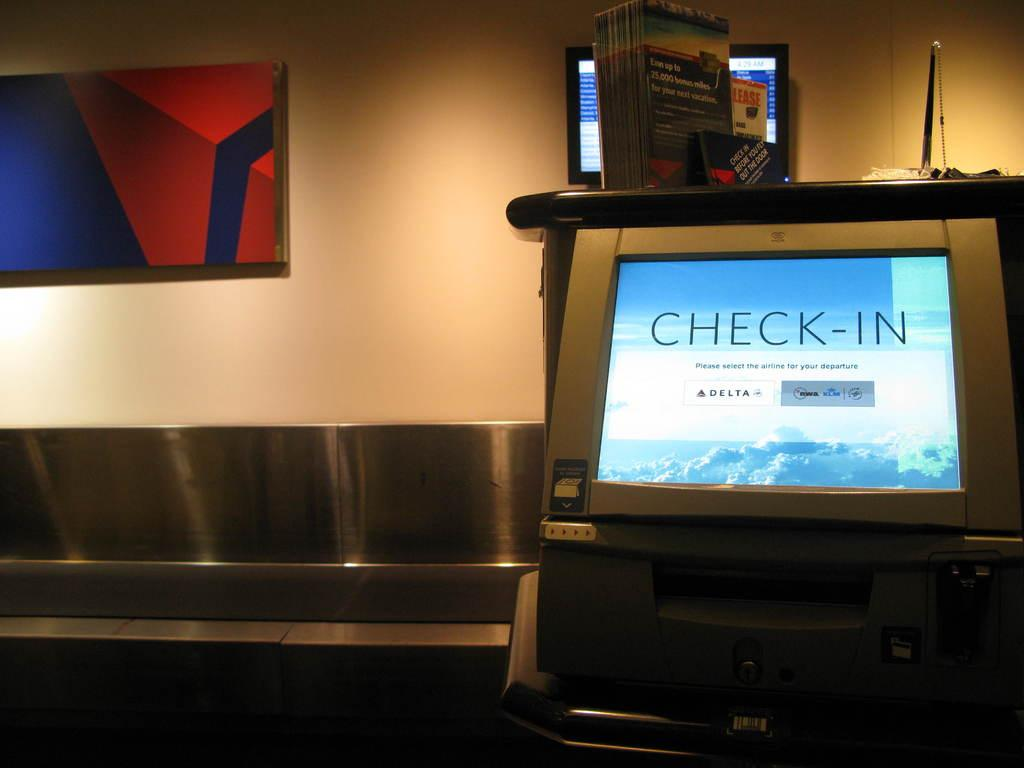Provide a one-sentence caption for the provided image. A check in computer at an airport in front of a silver device. 